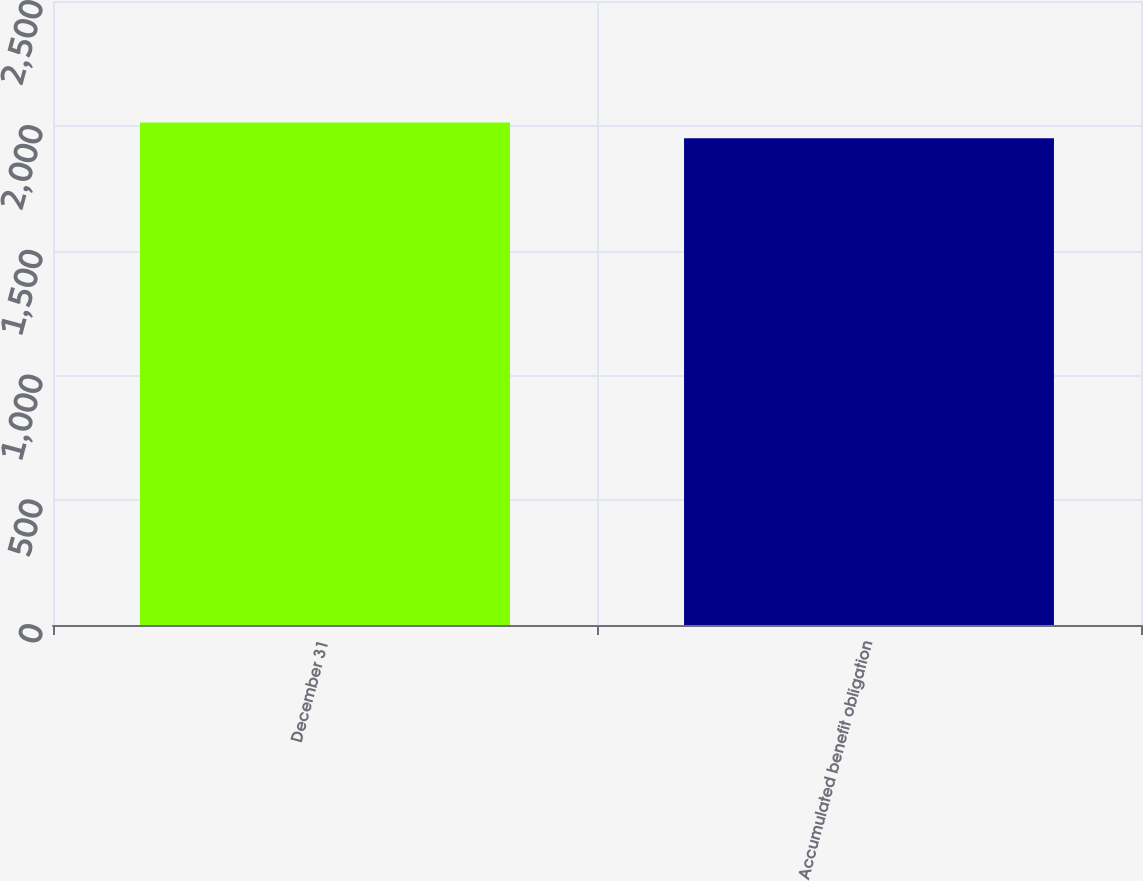Convert chart to OTSL. <chart><loc_0><loc_0><loc_500><loc_500><bar_chart><fcel>December 31<fcel>Accumulated benefit obligation<nl><fcel>2013<fcel>1950<nl></chart> 